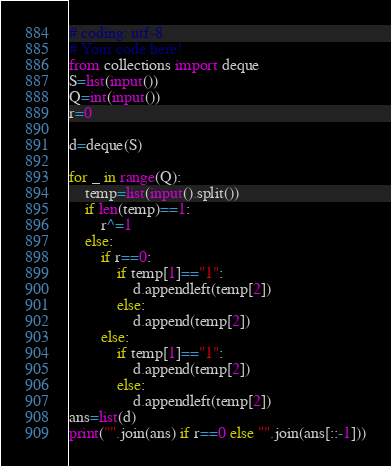Convert code to text. <code><loc_0><loc_0><loc_500><loc_500><_Python_># coding: utf-8
# Your code here!
from collections import deque
S=list(input())
Q=int(input())
r=0

d=deque(S)

for _ in range(Q):
    temp=list(input().split())
    if len(temp)==1:
        r^=1
    else:
        if r==0:
            if temp[1]=="1":
                d.appendleft(temp[2])
            else:
                d.append(temp[2])
        else:
            if temp[1]=="1":
                d.append(temp[2])
            else:
                d.appendleft(temp[2])
ans=list(d)
print("".join(ans) if r==0 else "".join(ans[::-1]))
</code> 